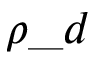Convert formula to latex. <formula><loc_0><loc_0><loc_500><loc_500>\rho \_ d</formula> 